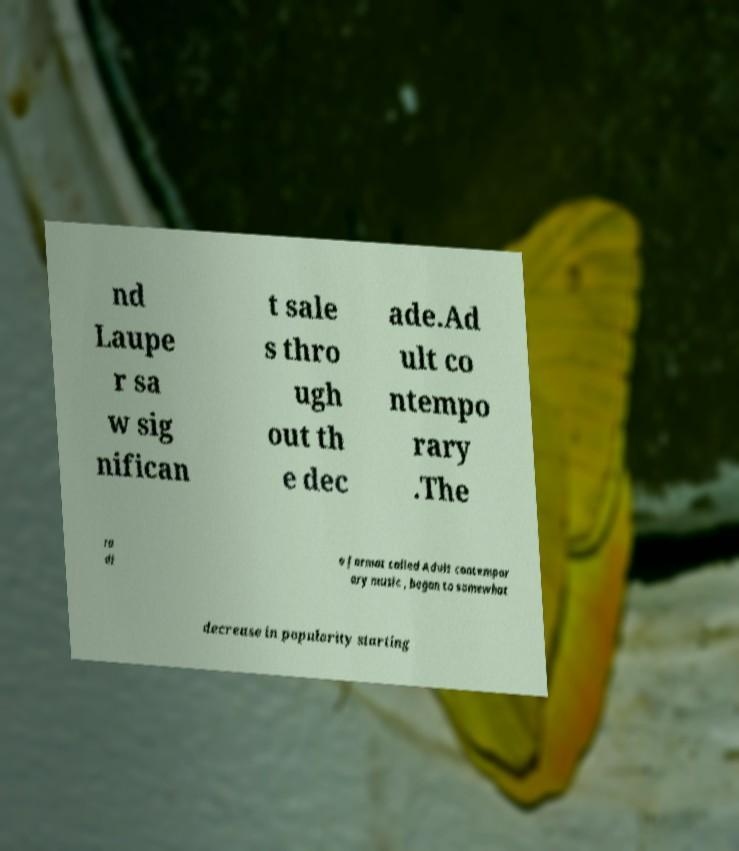Can you read and provide the text displayed in the image?This photo seems to have some interesting text. Can you extract and type it out for me? nd Laupe r sa w sig nifican t sale s thro ugh out th e dec ade.Ad ult co ntempo rary .The ra di o format called Adult contempor ary music , began to somewhat decrease in popularity starting 